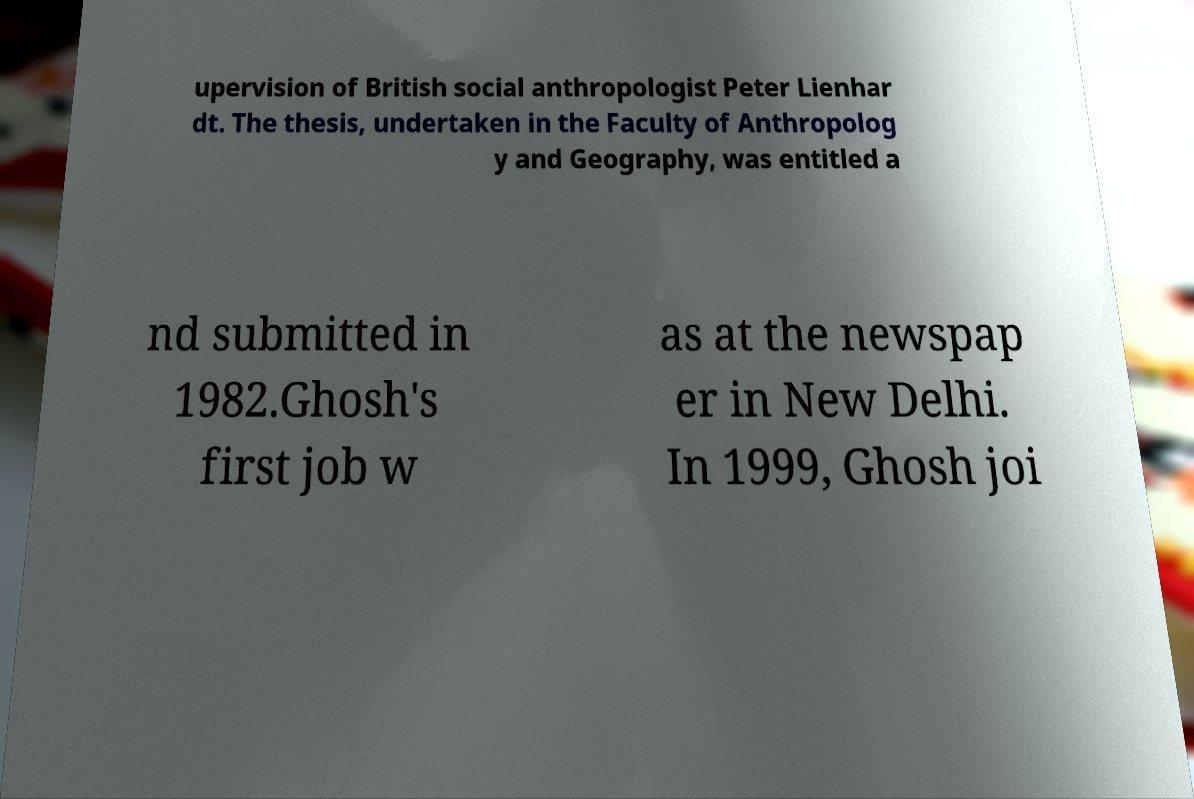Could you extract and type out the text from this image? upervision of British social anthropologist Peter Lienhar dt. The thesis, undertaken in the Faculty of Anthropolog y and Geography, was entitled a nd submitted in 1982.Ghosh's first job w as at the newspap er in New Delhi. In 1999, Ghosh joi 